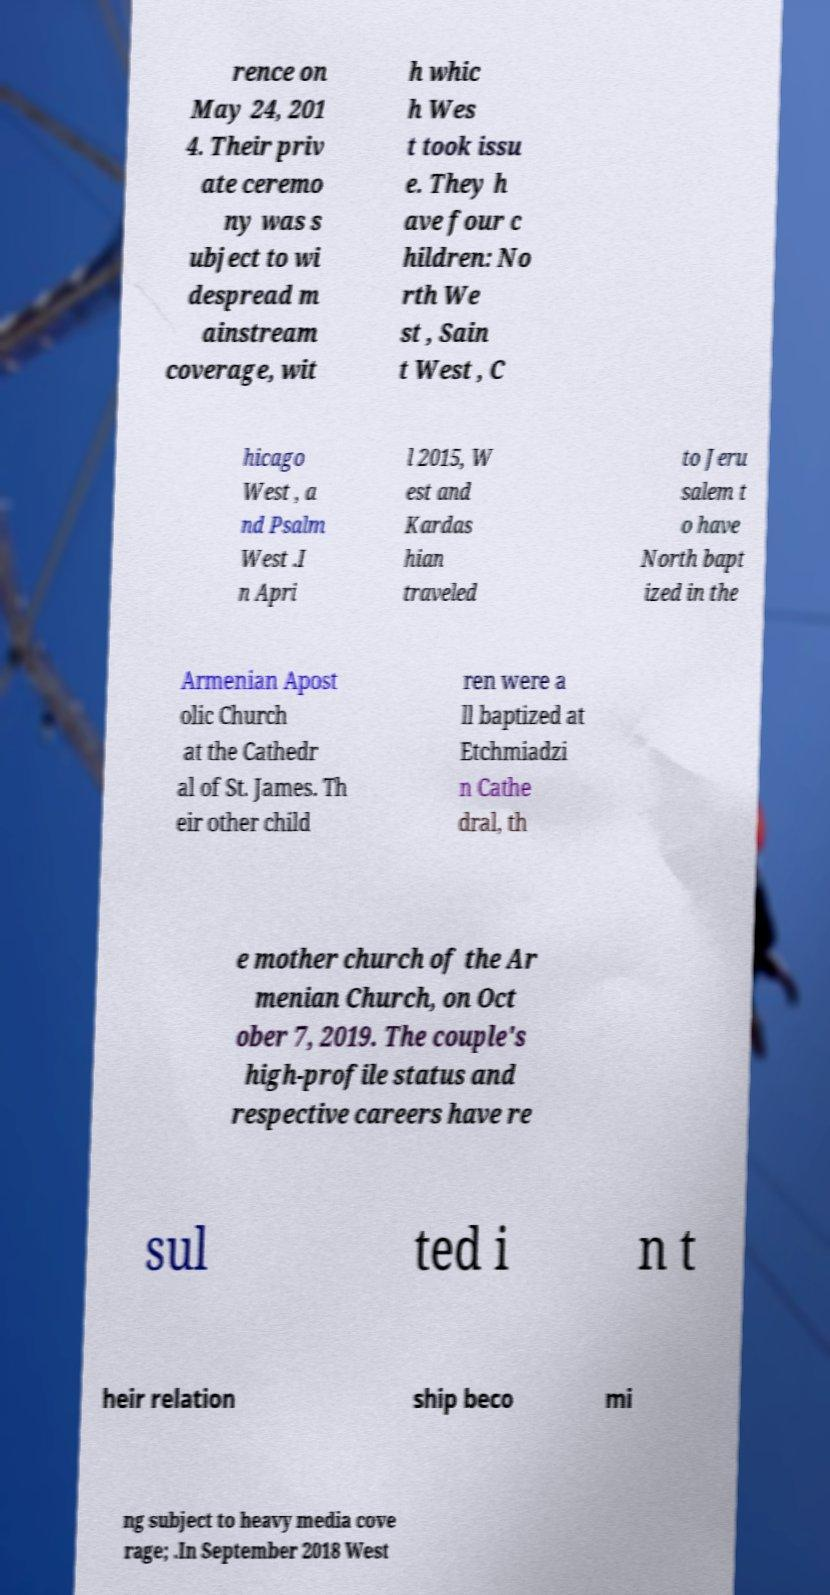What messages or text are displayed in this image? I need them in a readable, typed format. rence on May 24, 201 4. Their priv ate ceremo ny was s ubject to wi despread m ainstream coverage, wit h whic h Wes t took issu e. They h ave four c hildren: No rth We st , Sain t West , C hicago West , a nd Psalm West .I n Apri l 2015, W est and Kardas hian traveled to Jeru salem t o have North bapt ized in the Armenian Apost olic Church at the Cathedr al of St. James. Th eir other child ren were a ll baptized at Etchmiadzi n Cathe dral, th e mother church of the Ar menian Church, on Oct ober 7, 2019. The couple's high-profile status and respective careers have re sul ted i n t heir relation ship beco mi ng subject to heavy media cove rage; .In September 2018 West 